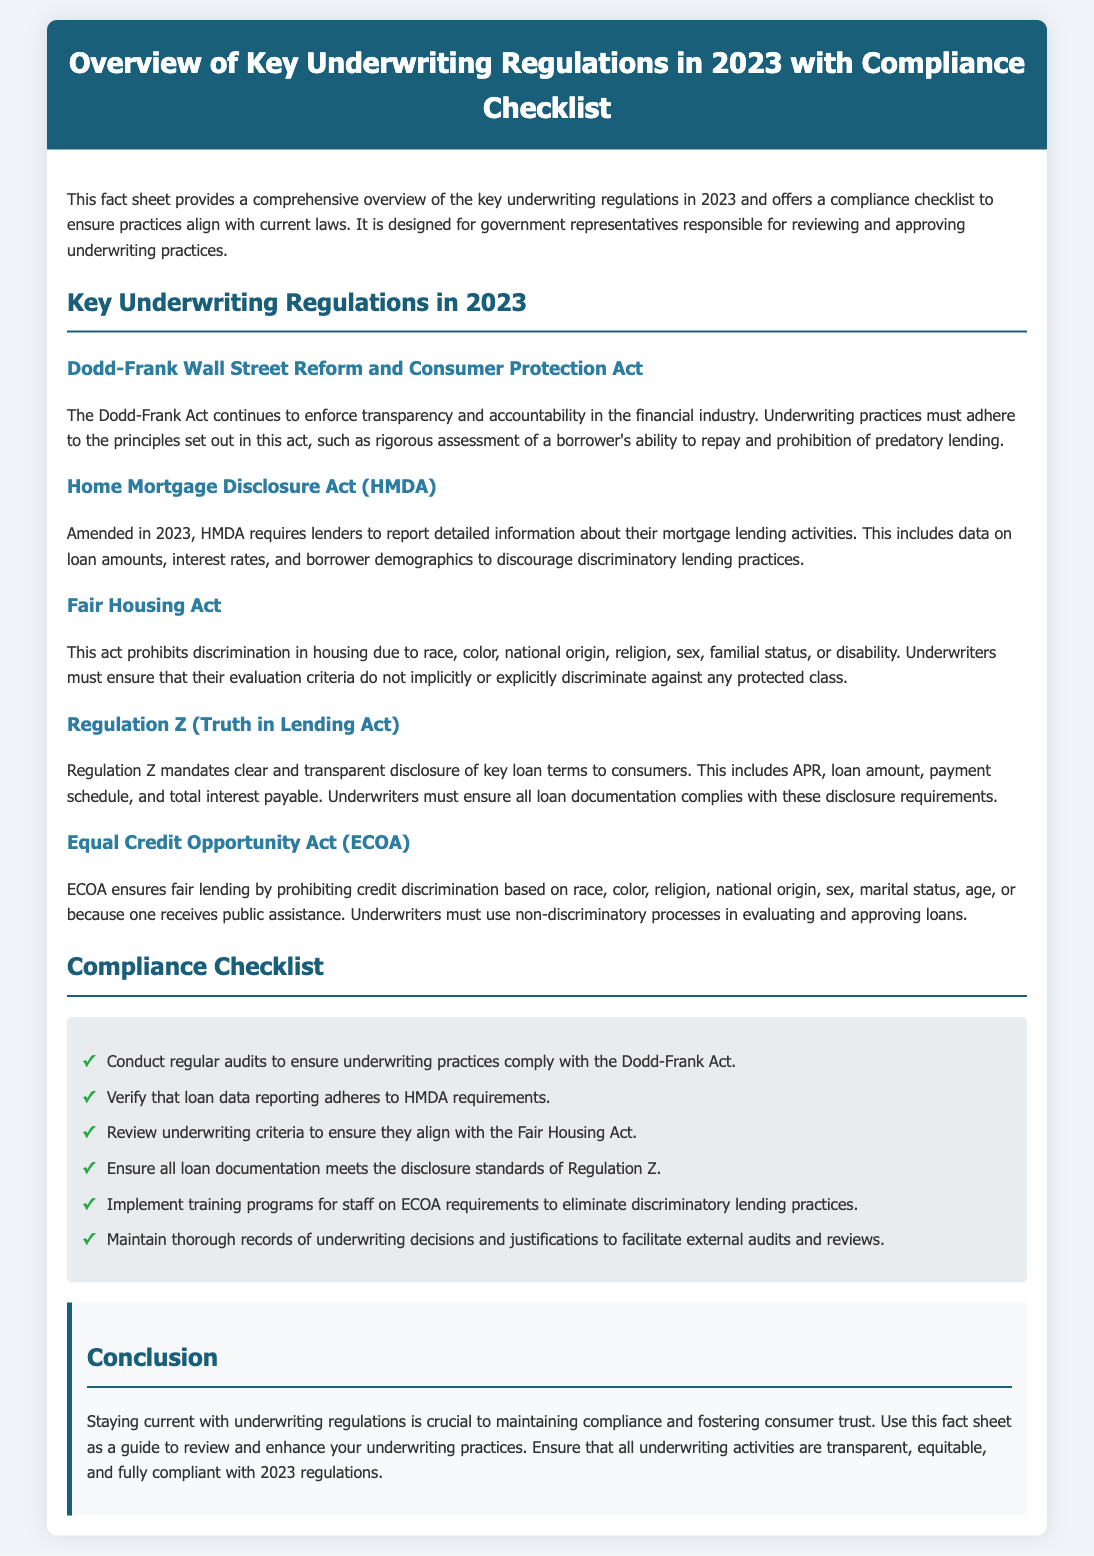what act enhances transparency and accountability in the financial industry? The Dodd-Frank Wall Street Reform and Consumer Protection Act is mentioned as the act enforcing transparency and accountability in the financial industry.
Answer: Dodd-Frank Act what regulation requires reporting of detailed mortgage lending information? The Home Mortgage Disclosure Act (HMDA) is noted for requiring lenders to report detailed information about mortgage lending activities.
Answer: HMDA what is the main purpose of the Fair Housing Act? The Fair Housing Act prohibits discrimination in housing based on various protected classes.
Answer: Prohibit discrimination how many items are listed in the compliance checklist? The compliance checklist contains a total of six items for ensuring adherence to regulations.
Answer: Six what does Regulation Z mandate regarding loan documentation? Regulation Z mandates clear and transparent disclosure of key loan terms, including the APR and other details.
Answer: Clear disclosure which act ensures fair lending practices? The Equal Credit Opportunity Act (ECOA) ensures fair lending by prohibiting credit discrimination.
Answer: ECOA what is emphasized as crucial for maintaining compliance in underwriting? Staying current with underwriting regulations is emphasized as crucial for maintaining compliance.
Answer: Staying current which category of regulations emphasizes non-discriminatory processes? The Equal Credit Opportunity Act (ECOA) emphasizes non-discriminatory processes in evaluating loans.
Answer: ECOA what color is used for the header background in the document? The header background is styled with a specific dark color.
Answer: Dark blue 